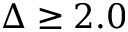Convert formula to latex. <formula><loc_0><loc_0><loc_500><loc_500>\Delta \geq 2 . 0</formula> 